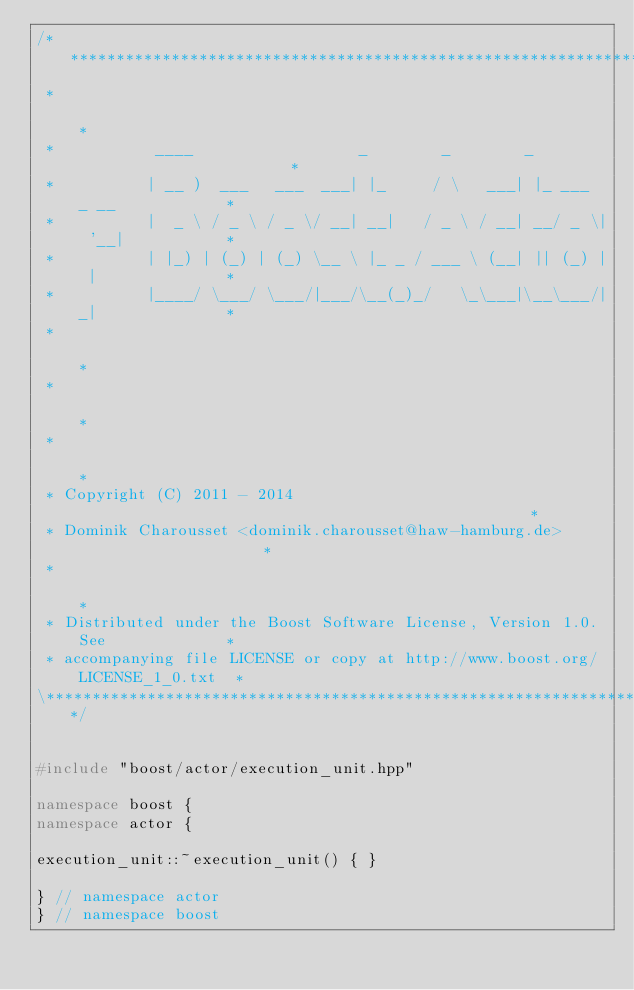Convert code to text. <code><loc_0><loc_0><loc_500><loc_500><_C++_>/******************************************************************************\
 *                                                                            *
 *           ____                  _        _        _                        *
 *          | __ )  ___   ___  ___| |_     / \   ___| |_ ___  _ __            *
 *          |  _ \ / _ \ / _ \/ __| __|   / _ \ / __| __/ _ \| '__|           *
 *          | |_) | (_) | (_) \__ \ |_ _ / ___ \ (__| || (_) | |              *
 *          |____/ \___/ \___/|___/\__(_)_/   \_\___|\__\___/|_|              *
 *                                                                            *
 *                                                                            *
 *                                                                            *
 * Copyright (C) 2011 - 2014                                                  *
 * Dominik Charousset <dominik.charousset@haw-hamburg.de>                     *
 *                                                                            *
 * Distributed under the Boost Software License, Version 1.0. See             *
 * accompanying file LICENSE or copy at http://www.boost.org/LICENSE_1_0.txt  *
\******************************************************************************/


#include "boost/actor/execution_unit.hpp"

namespace boost {
namespace actor {

execution_unit::~execution_unit() { }

} // namespace actor
} // namespace boost
</code> 